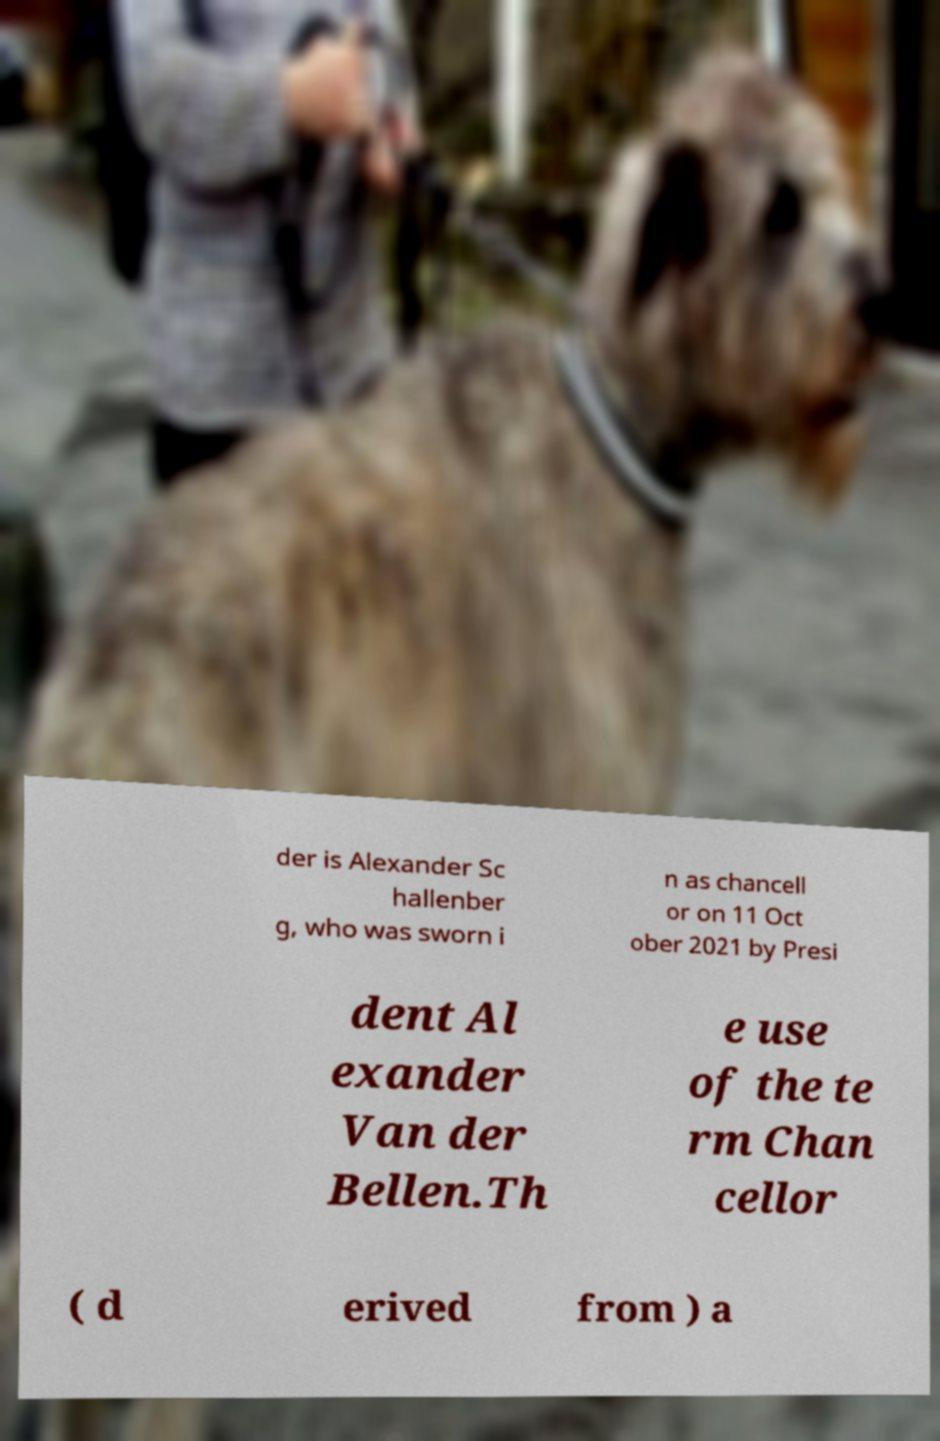For documentation purposes, I need the text within this image transcribed. Could you provide that? der is Alexander Sc hallenber g, who was sworn i n as chancell or on 11 Oct ober 2021 by Presi dent Al exander Van der Bellen.Th e use of the te rm Chan cellor ( d erived from ) a 